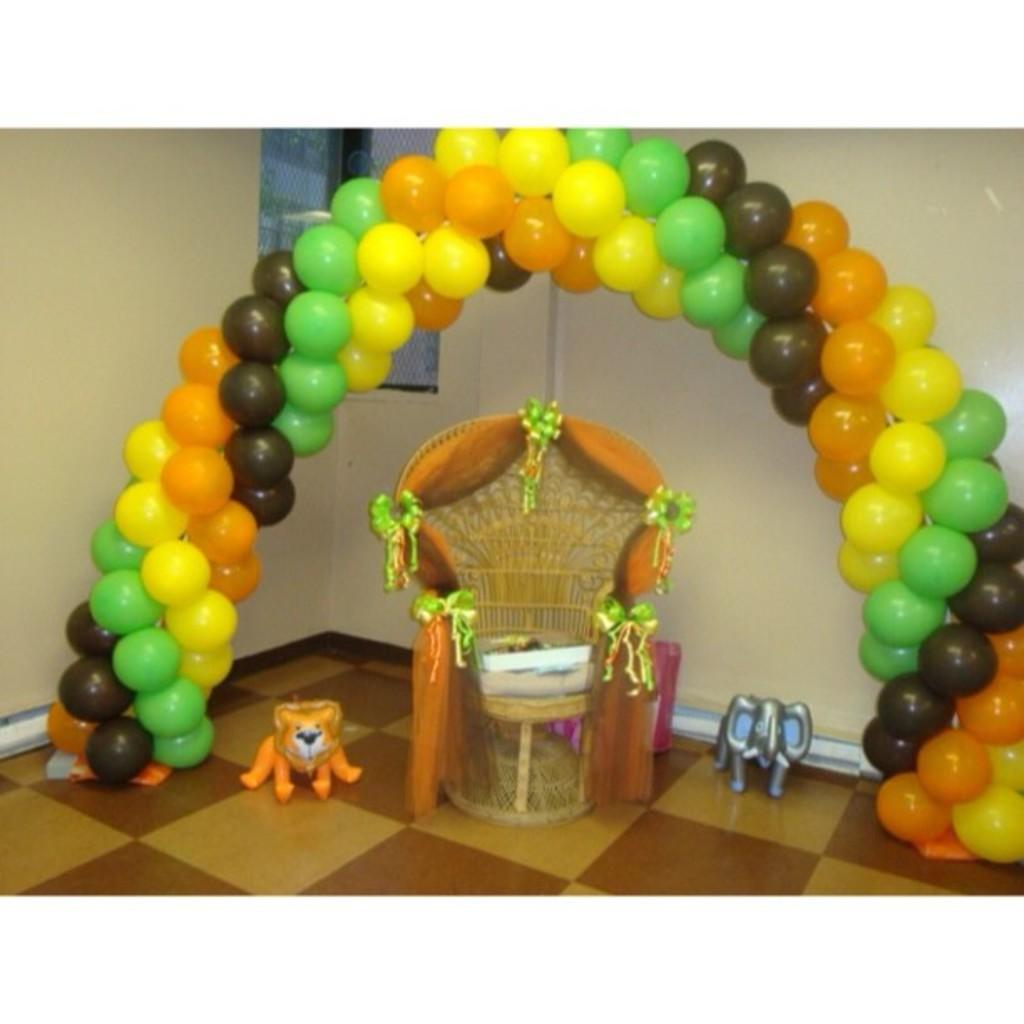What type of objects can be seen in the image? There are toys and balloons in the image. What is on the floor in the image? There is a decorative object on the floor. What can be seen in the background of the image? There is a wall and a window in the background of the image. What type of rail is present in the image? There is no rail present in the image. How many baskets can be seen in the image? There are no baskets present in the image. 